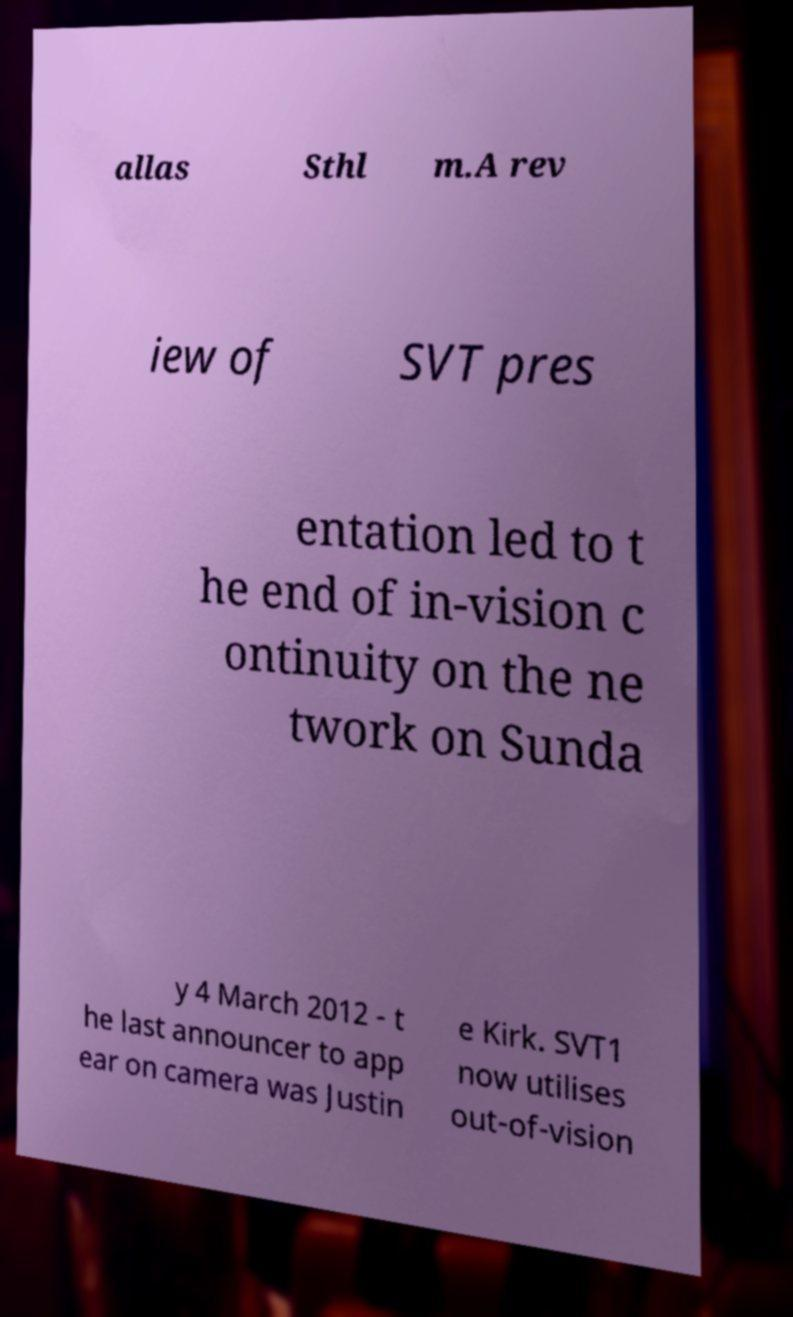There's text embedded in this image that I need extracted. Can you transcribe it verbatim? allas Sthl m.A rev iew of SVT pres entation led to t he end of in-vision c ontinuity on the ne twork on Sunda y 4 March 2012 - t he last announcer to app ear on camera was Justin e Kirk. SVT1 now utilises out-of-vision 